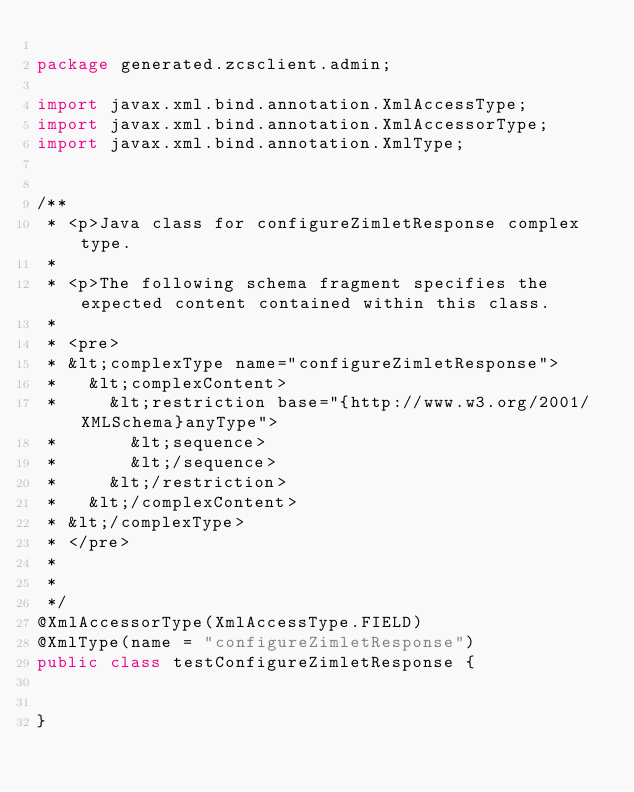Convert code to text. <code><loc_0><loc_0><loc_500><loc_500><_Java_>
package generated.zcsclient.admin;

import javax.xml.bind.annotation.XmlAccessType;
import javax.xml.bind.annotation.XmlAccessorType;
import javax.xml.bind.annotation.XmlType;


/**
 * <p>Java class for configureZimletResponse complex type.
 * 
 * <p>The following schema fragment specifies the expected content contained within this class.
 * 
 * <pre>
 * &lt;complexType name="configureZimletResponse">
 *   &lt;complexContent>
 *     &lt;restriction base="{http://www.w3.org/2001/XMLSchema}anyType">
 *       &lt;sequence>
 *       &lt;/sequence>
 *     &lt;/restriction>
 *   &lt;/complexContent>
 * &lt;/complexType>
 * </pre>
 * 
 * 
 */
@XmlAccessorType(XmlAccessType.FIELD)
@XmlType(name = "configureZimletResponse")
public class testConfigureZimletResponse {


}
</code> 